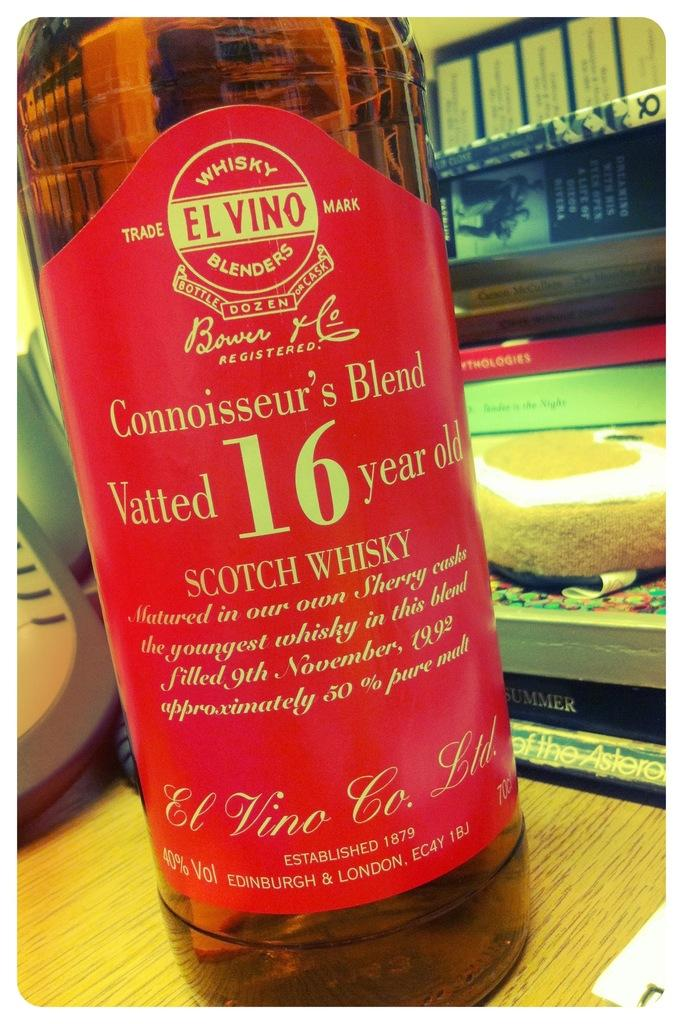Provide a one-sentence caption for the provided image. A close up of the red label of a bottle of Elvino 16 year old whisky. 